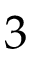Convert formula to latex. <formula><loc_0><loc_0><loc_500><loc_500>3</formula> 